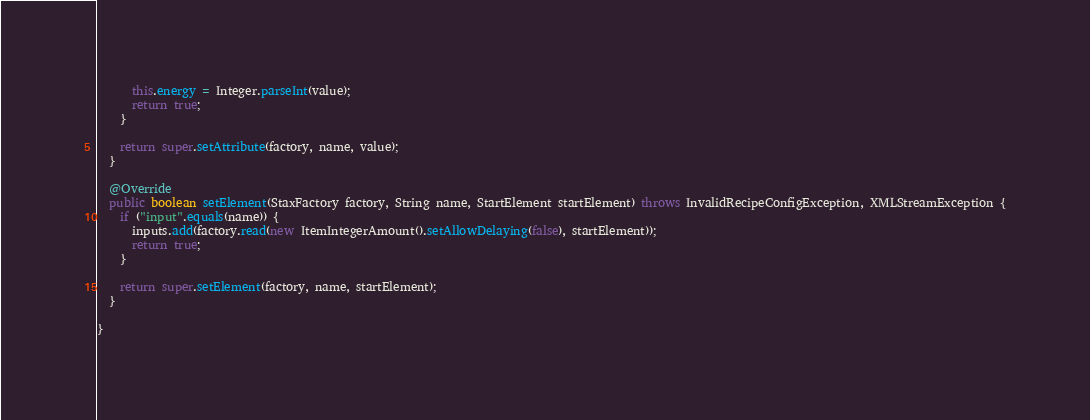<code> <loc_0><loc_0><loc_500><loc_500><_Java_>      this.energy = Integer.parseInt(value);
      return true;
    }

    return super.setAttribute(factory, name, value);
  }

  @Override
  public boolean setElement(StaxFactory factory, String name, StartElement startElement) throws InvalidRecipeConfigException, XMLStreamException {
    if ("input".equals(name)) {
      inputs.add(factory.read(new ItemIntegerAmount().setAllowDelaying(false), startElement));
      return true;
    }

    return super.setElement(factory, name, startElement);
  }

}</code> 